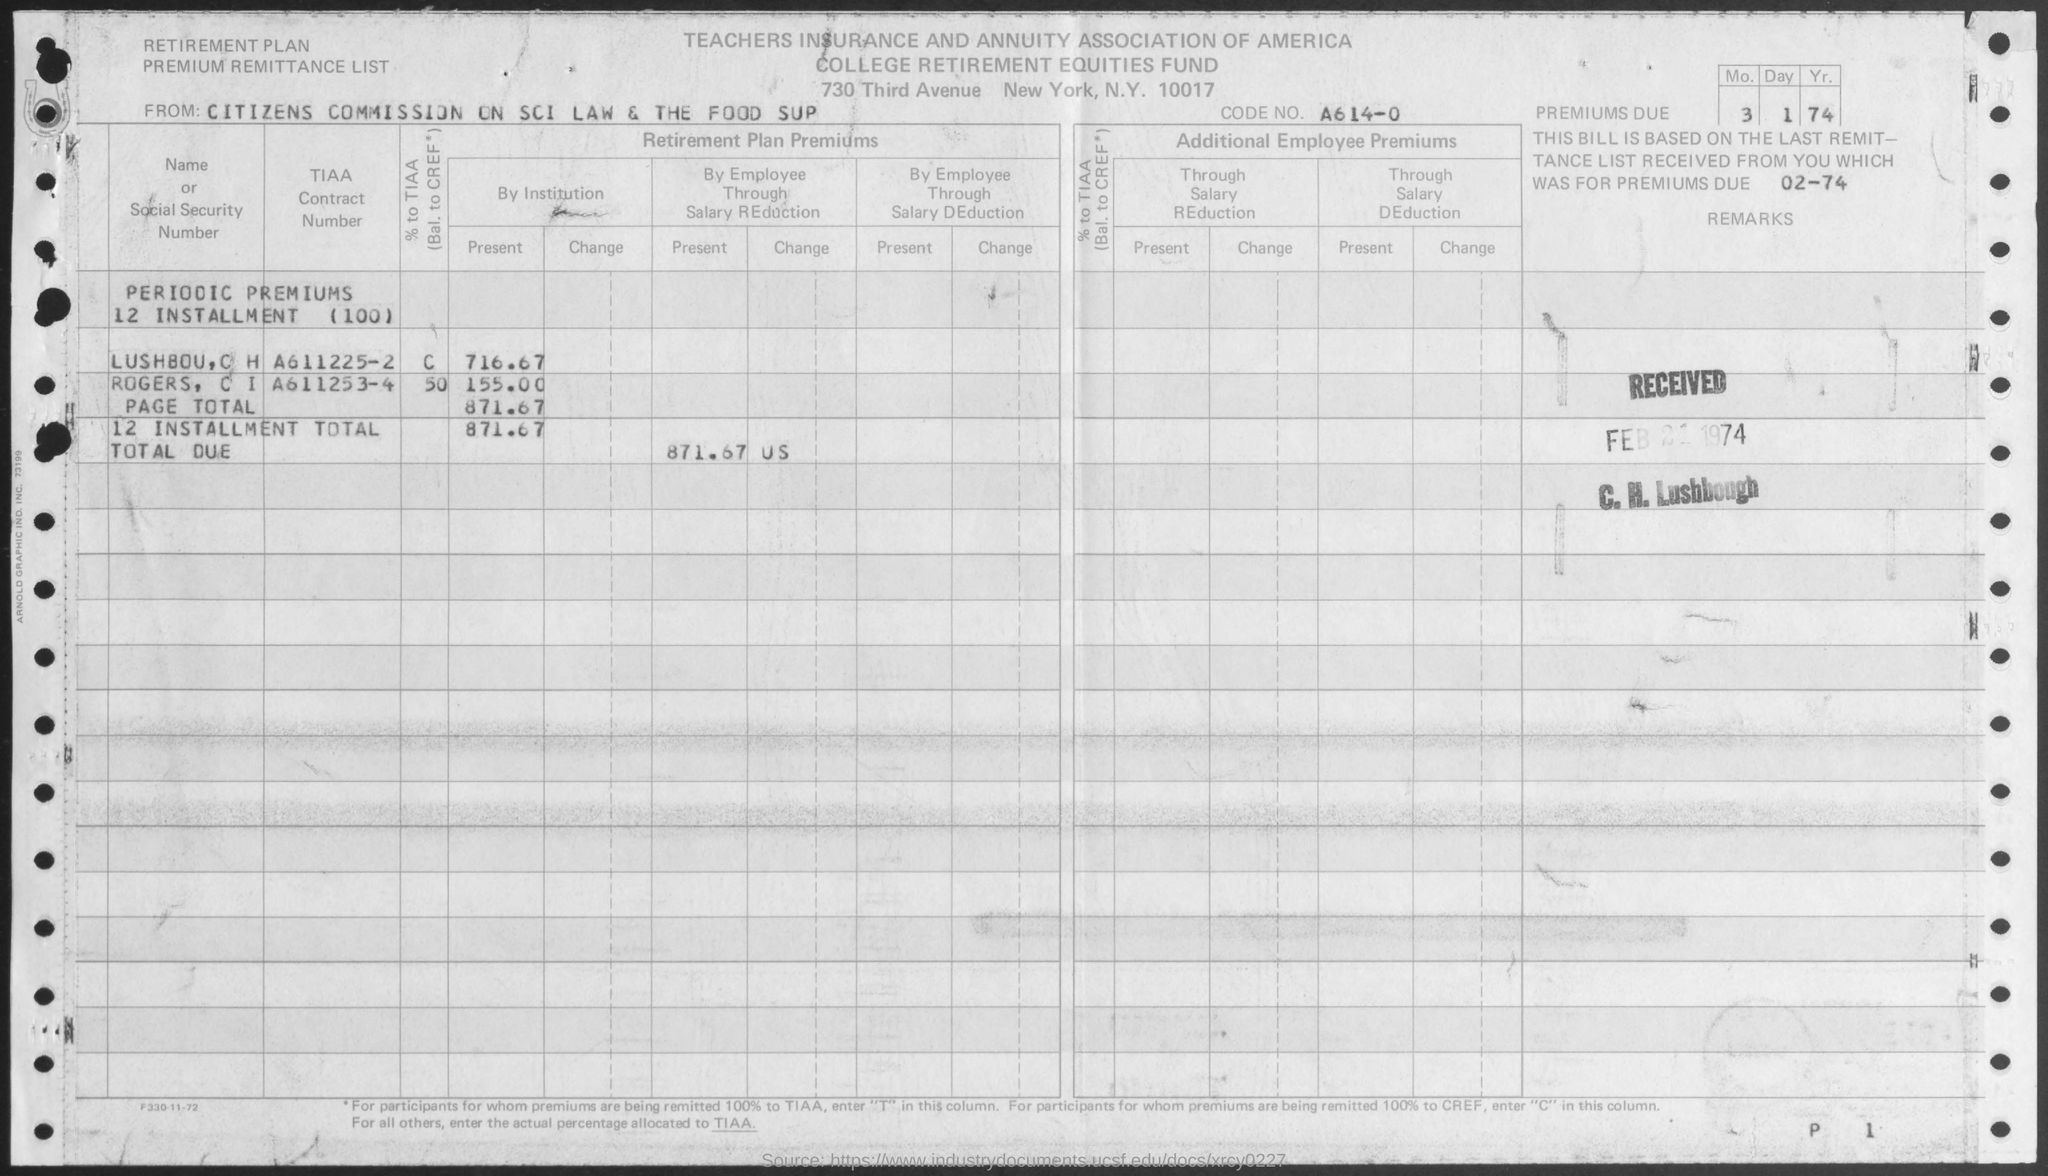From whom is the document?
Keep it short and to the point. Citizens Commission on SCI Law & The Food SUP. What is the CODE NO.?
Give a very brief answer. A614-0. What is the total due?
Provide a succinct answer. 871.67 US. 